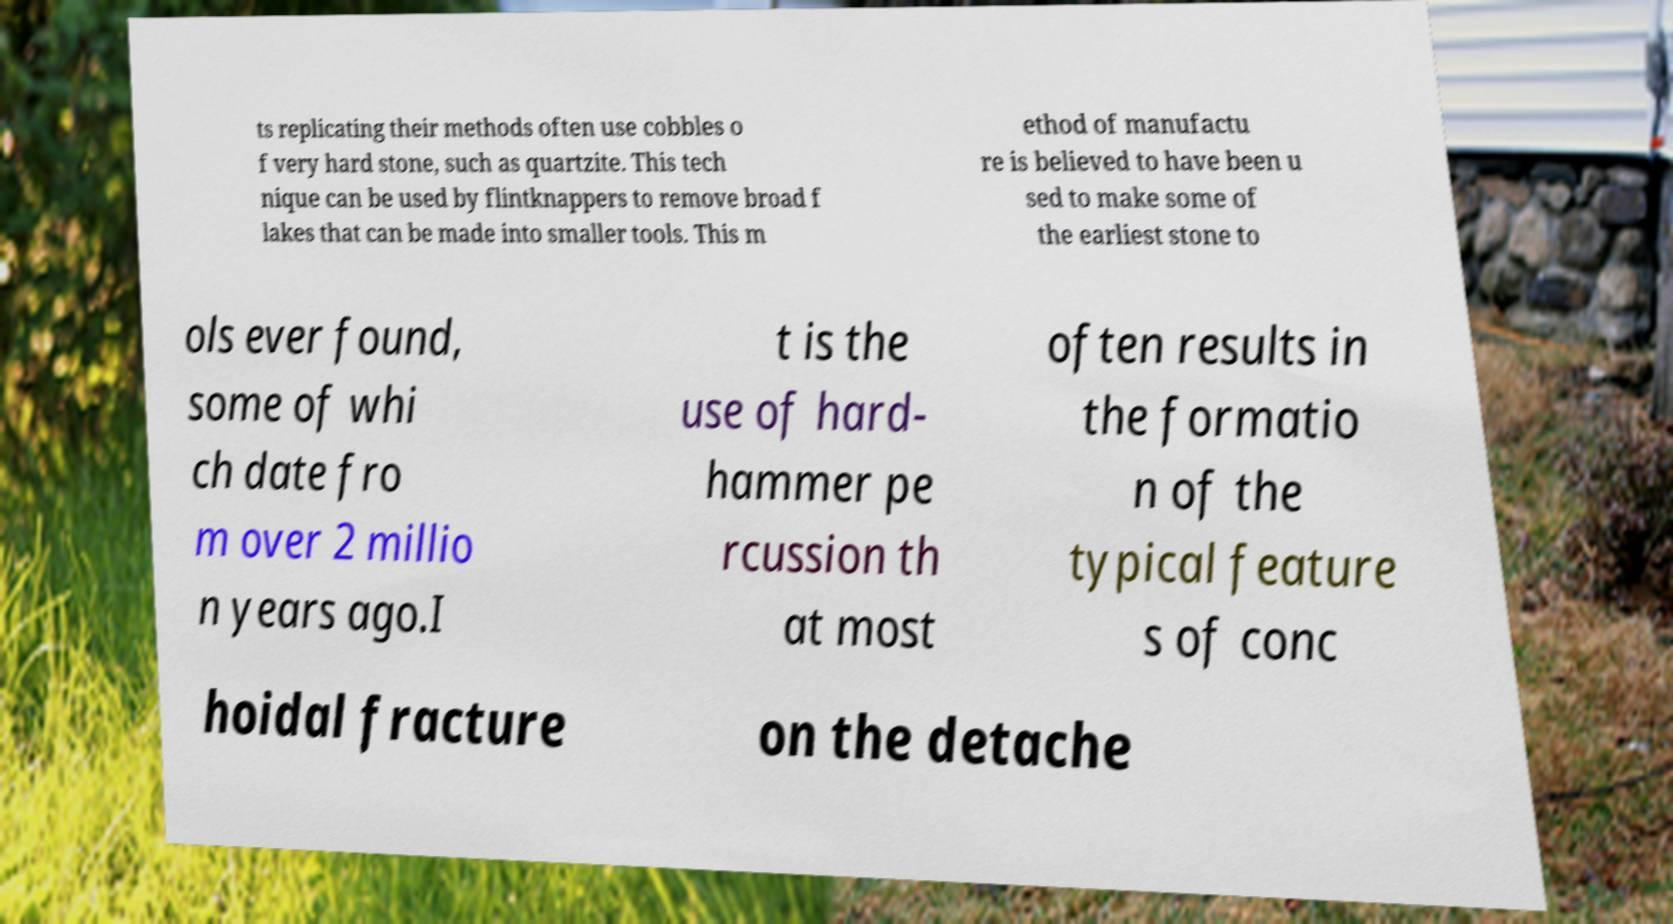Please identify and transcribe the text found in this image. ts replicating their methods often use cobbles o f very hard stone, such as quartzite. This tech nique can be used by flintknappers to remove broad f lakes that can be made into smaller tools. This m ethod of manufactu re is believed to have been u sed to make some of the earliest stone to ols ever found, some of whi ch date fro m over 2 millio n years ago.I t is the use of hard- hammer pe rcussion th at most often results in the formatio n of the typical feature s of conc hoidal fracture on the detache 